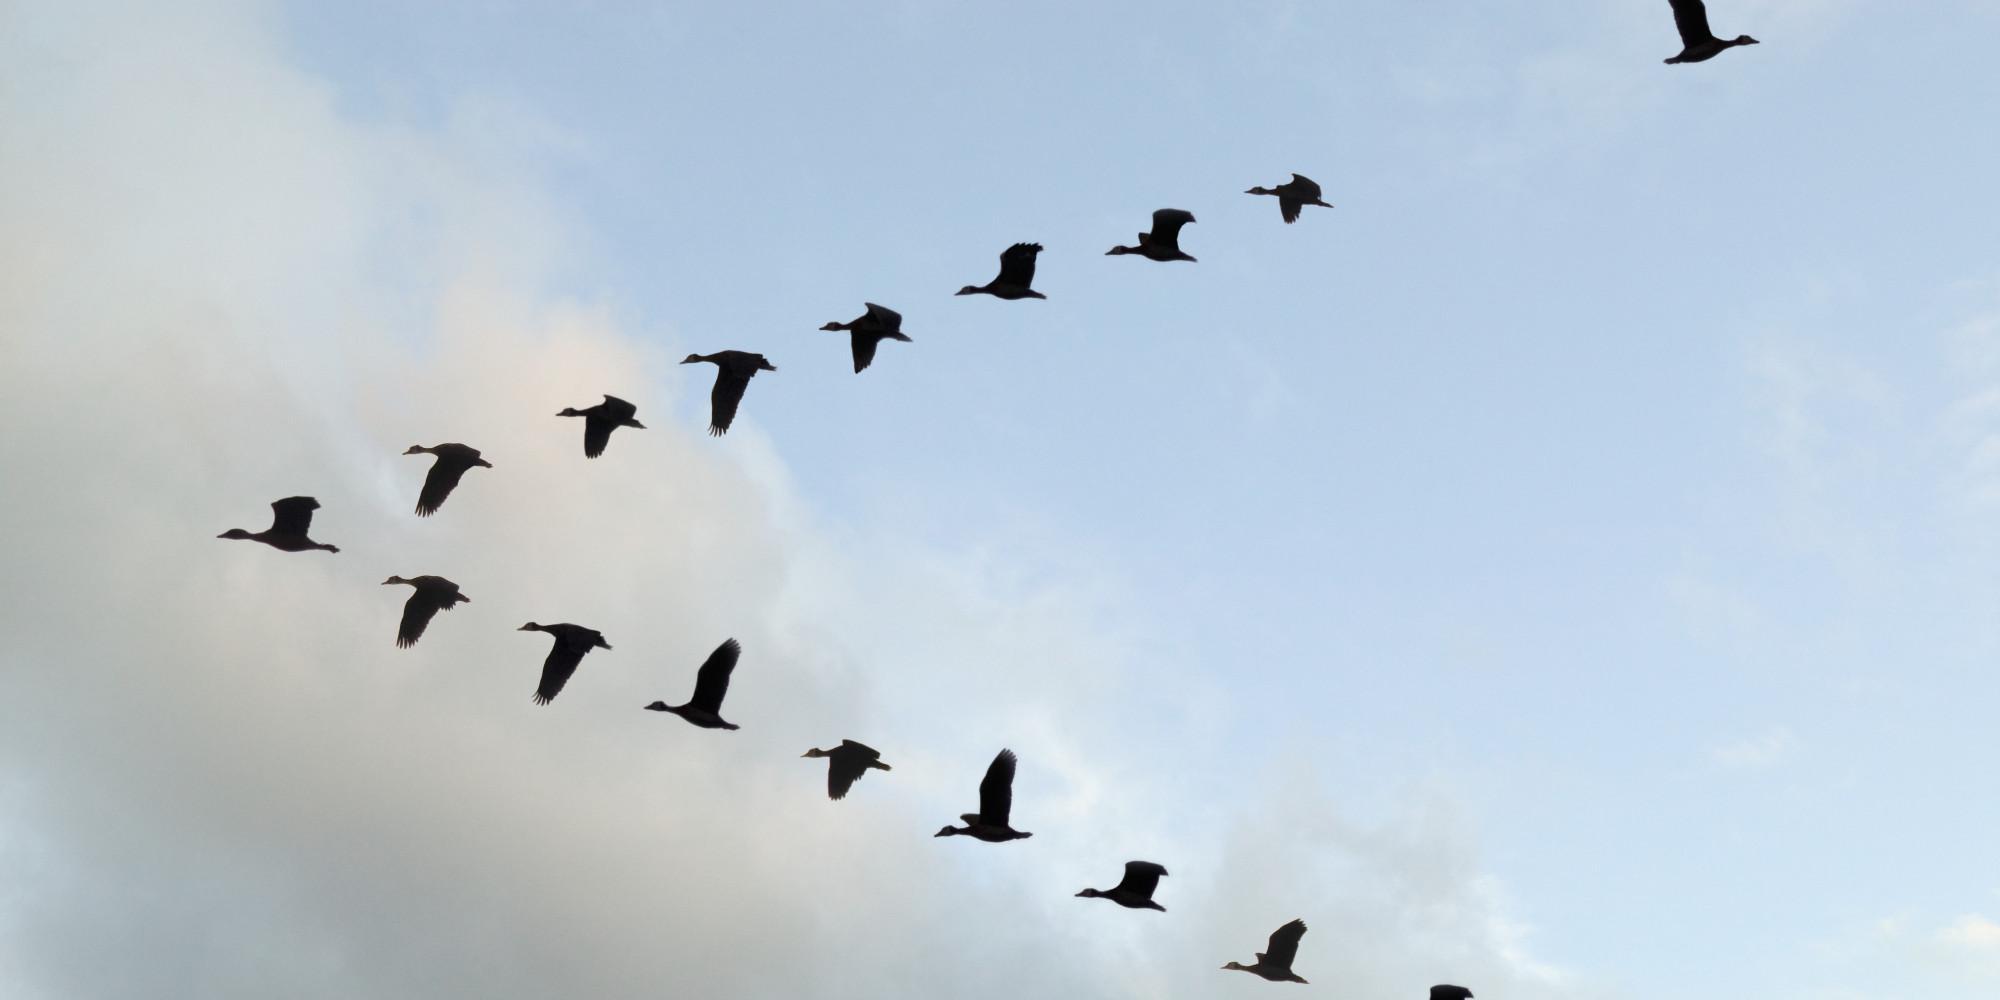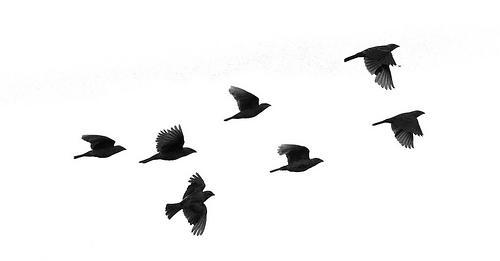The first image is the image on the left, the second image is the image on the right. Evaluate the accuracy of this statement regarding the images: "The birds in the image on the right are flying in a v formation.". Is it true? Answer yes or no. No. The first image is the image on the left, the second image is the image on the right. Evaluate the accuracy of this statement regarding the images: "There are many more than 40 birds in total.". Is it true? Answer yes or no. No. 